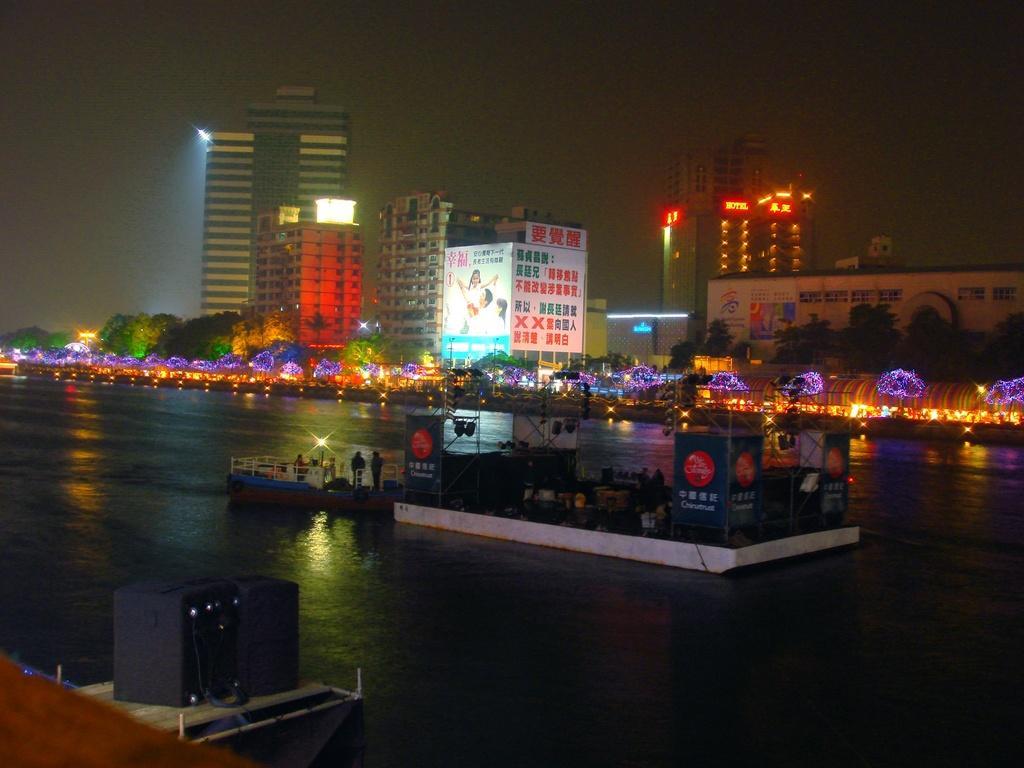Describe this image in one or two sentences. In this image, we can see a rectangle shape object above the water. Beside that, we can see a boat with railing. Here we can see few people, rods, banners and few things. At the bottom of the image, we can see rods, some objects. Background we can see buildings, trees, lights, digital screens and some text. 